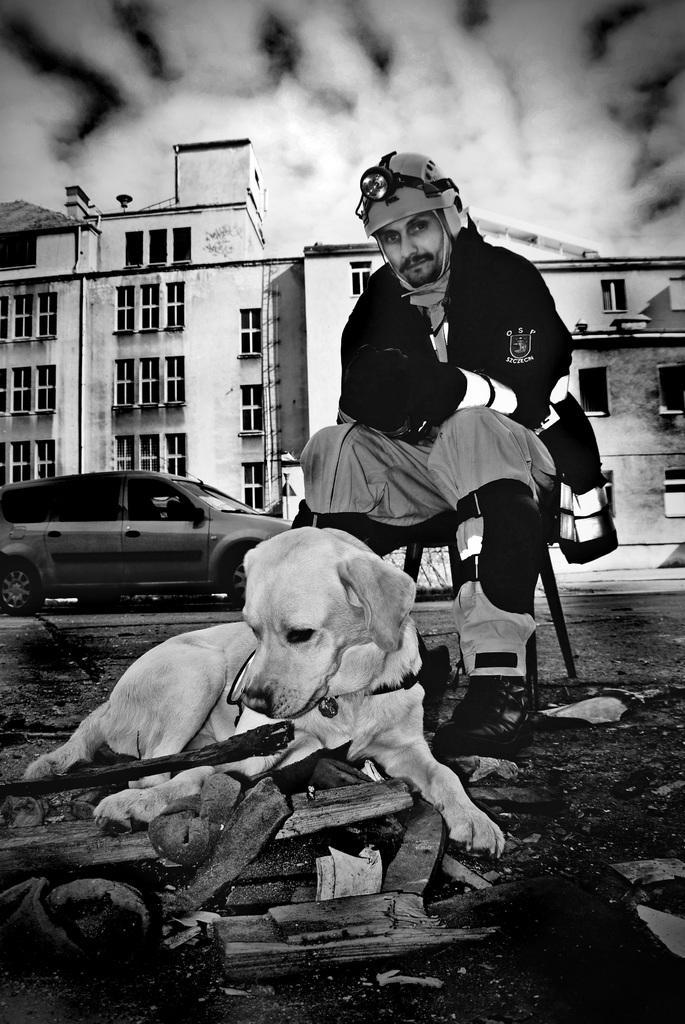In one or two sentences, can you explain what this image depicts? In this picture I can see a man is sitting in the chair and I can see a car and couple of buildings in the back and I can see a dog and few wooden sticks on the ground and I can see clouds. 